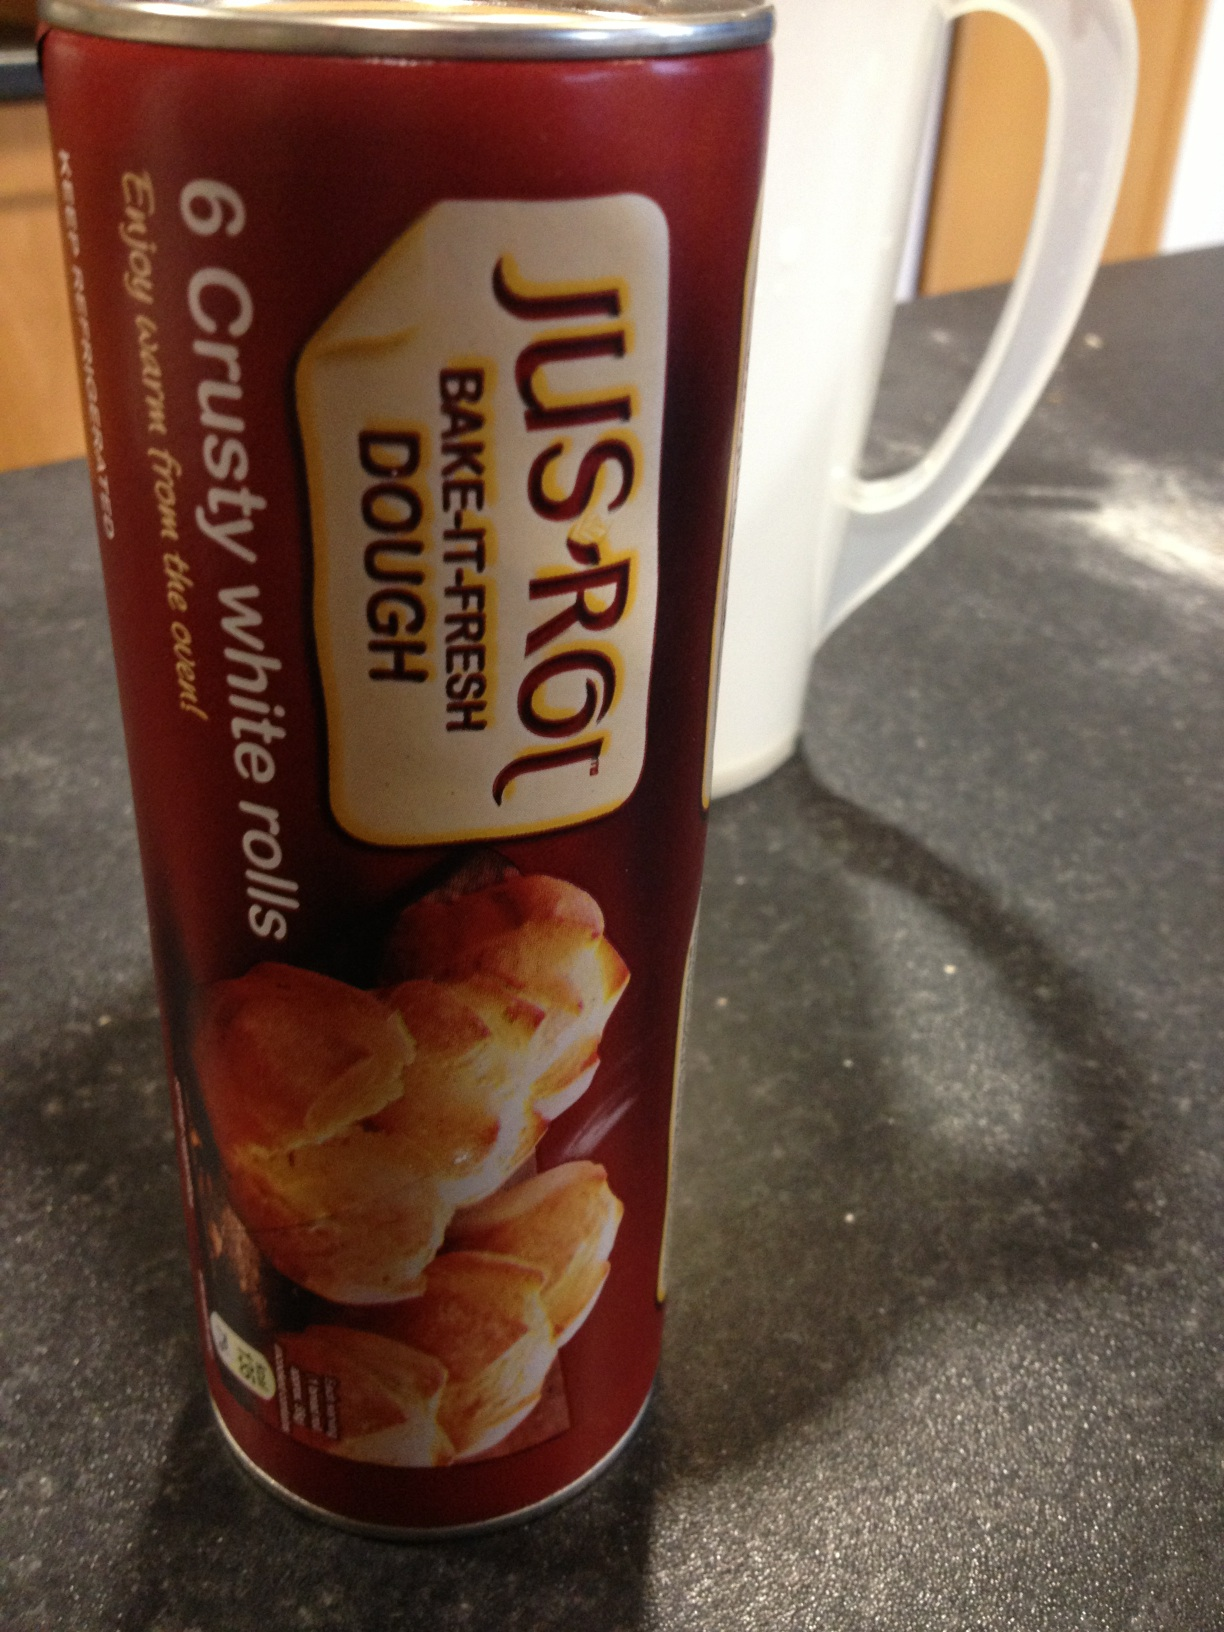What unique ways can I use this dough other than making traditional rolls? You can get very creative with Jus-Rol dough! Here are a few unique ideas: 
1. Make mini calzones by stuffing the dough with cheese, tomato sauce, and your favorite pizza toppings.
2. Create bite-sized savory snacks by wrapping the dough around small pieces of sausage or cheese.
3. Bake dough twists with cinnamon and sugar for a sweet treat.
4. Make garlic knots by tying the dough into knots and brushing with garlic butter before baking.
5. Use the dough to make small individual pot pies by filling them with your favorite savory pie filling. 